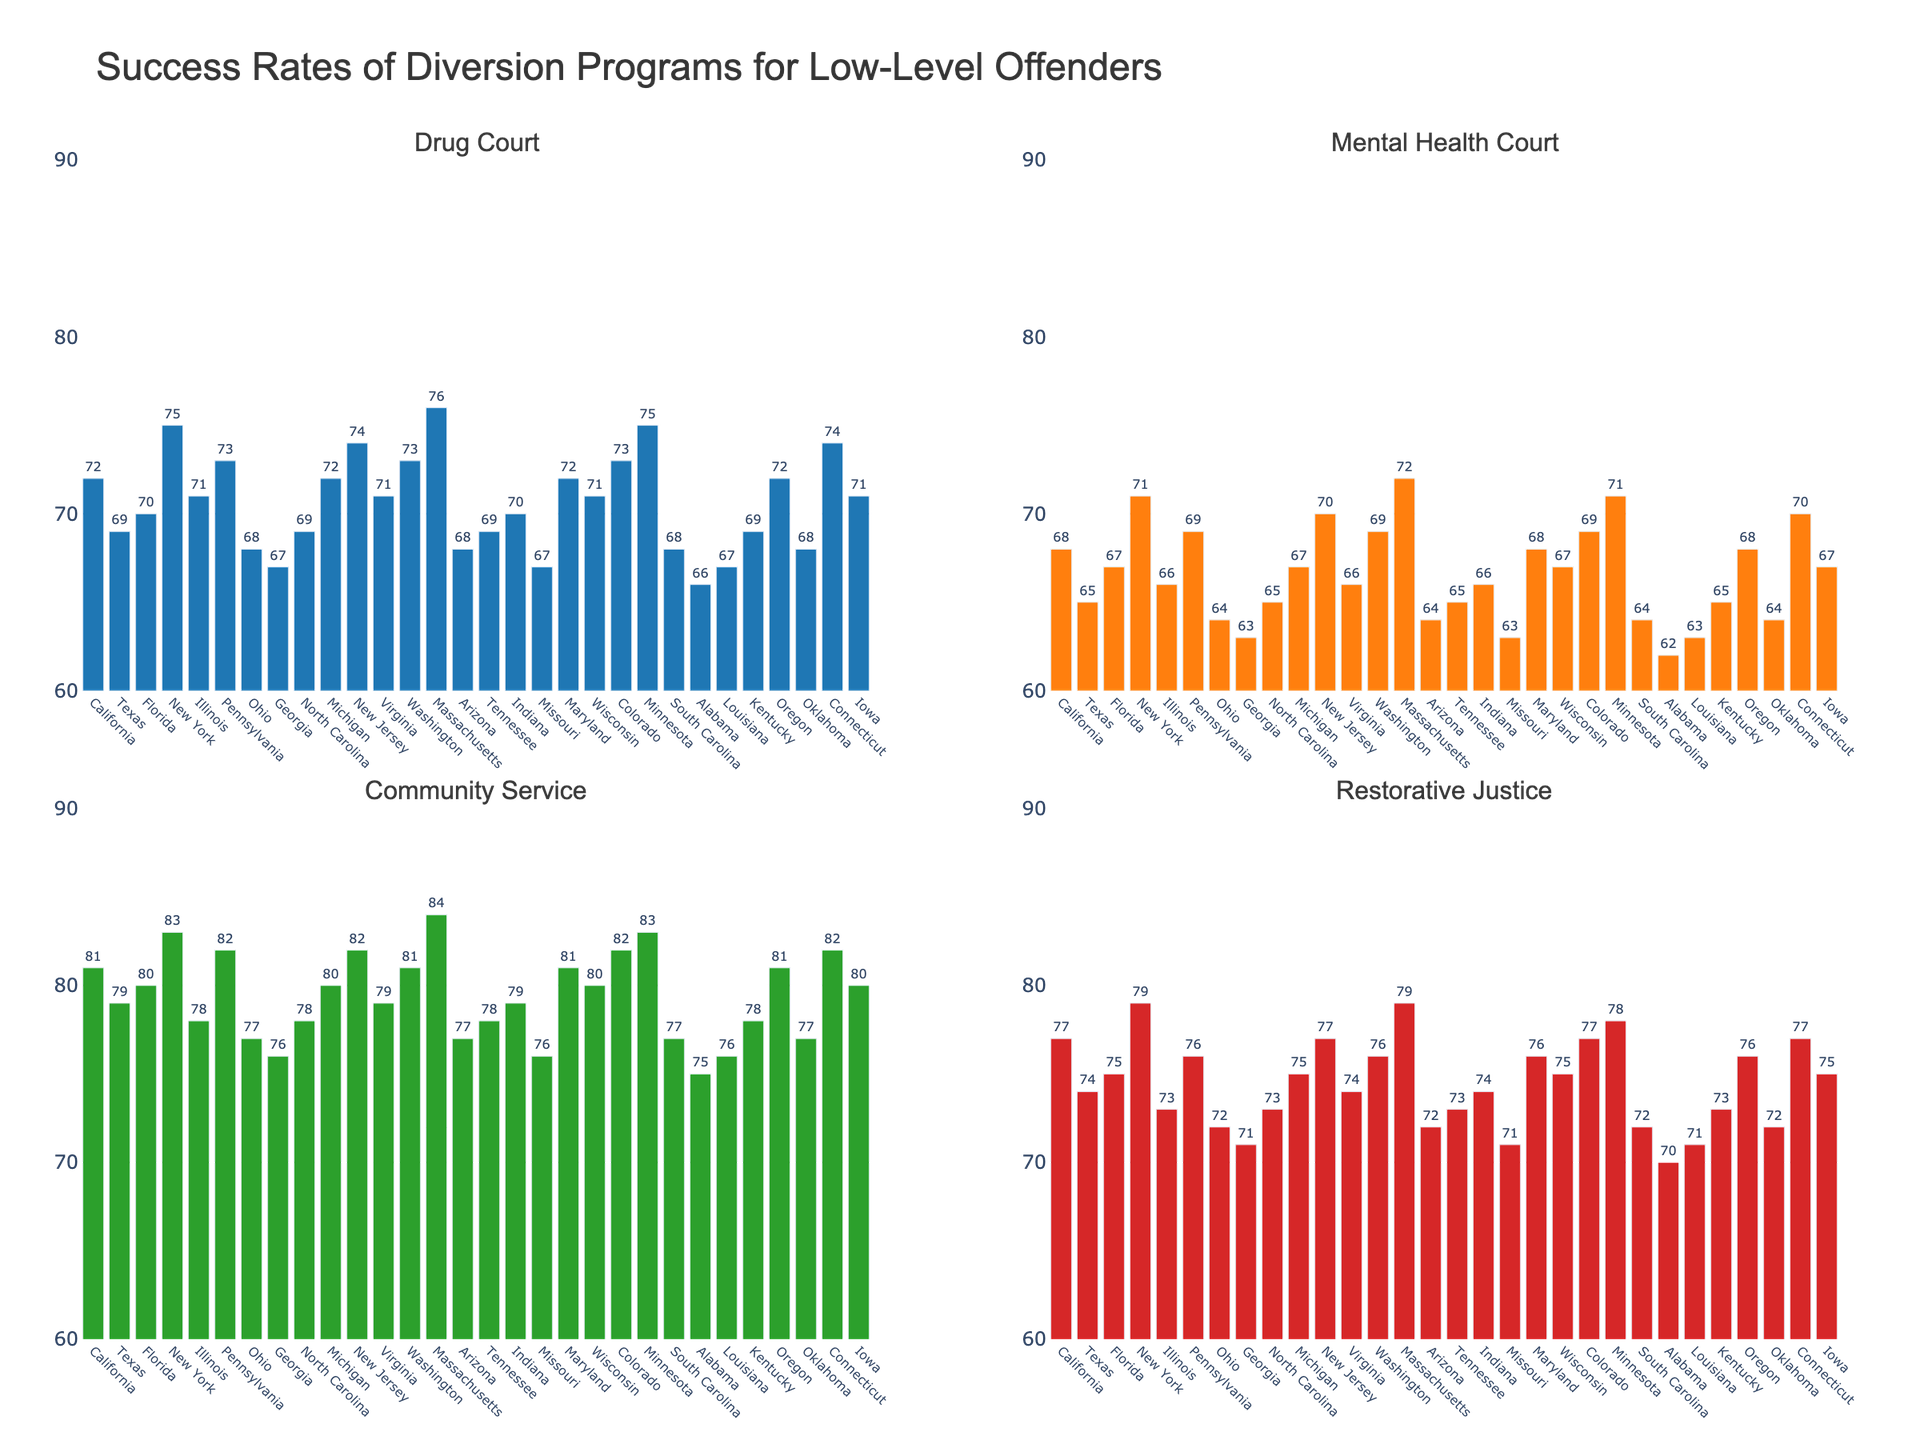what is the average success rate of drug courts in all states? Add the success rates of drug courts for all states and then divide by the number of states \( \frac{72+69+70+75+71+73+68+67+69+72+74+71+73+76+68+69+70+67+72+71+73+75+68+66+67+69+72+68+74+71}{30} \approx 71
Answer: 71 Which state has the highest community service success rate? Look at the bar heights in the community service subplot and find the highest one, which is for Massachusetts
Answer: Massachusetts Compare the success rates of drug courts and mental health courts in New York. Find the bars corresponding to New York in both subplots; drug courts have a success rate of 75 and mental health courts 71
Answer: Drug Courts have a higher success rate Are there any states where all diversion programs have a success rate of 70% or higher? Check each state to see if all four bars in their respective subplots are 70% or higher. Massachusetts fulfills this criterion
Answer: Massachusetts Which has a higher average success rate, community service programs or restorative justice programs across all states? Calculate the averages for each program and compare them: Community Service \( \frac{81+79+80+83+78+82+77+76+78+80+82+79+81+84+77+78+79+76+81+80+82+83+77+75+76+78+81+77+82+80}{30} \approx 79.33 \) and Restorative Justice \( \frac{77+74+75+79+73+76+72+71+73+75+77+74+76+79+72+73+74+71+76+75+77+78+72+70+71+73+76+72+77+75}{30} \approx 74.93 \)
Answer: Community service programs What is the difference in success rates between mental health courts and drug courts in Virginia? Look at the bars for Virginia: Drug Court has 71% and Mental Health Court has 66%, the difference is \(71-66=5
Answer: 5 Which states have drug courts success rates below 70%? Identify states with bars below 70% in the Drug Court subplot: Texas, Ohio, Georgia, Missouri, Arizona, South Carolina, Alabama, Louisiana
Answer: Texas, Ohio, Georgia, Missouri, Arizona, South Carolina, Alabama, Louisiana Is there any program in Texas that has a success rate higher than 75%? Look at the bar heights in the Texas segments for each subplot: Community Service (79) and Restorative Justice (74), drug courts (69), mental health (65), only Community Service has a rate higher than 75%
Answer: Yes, Community Service 